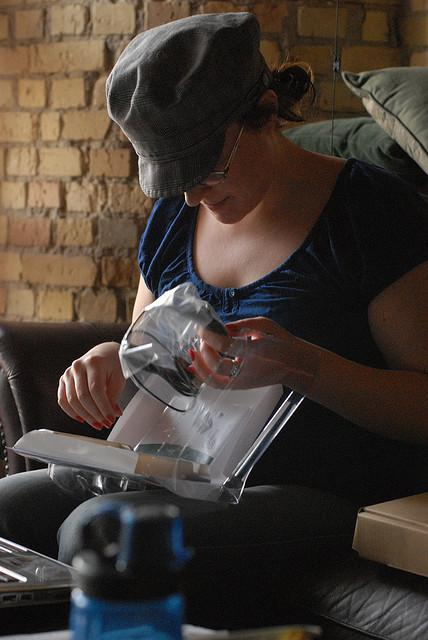What's the lady wearing on her head? Please explain your reasoning. cap. A cap is covering her hair. 